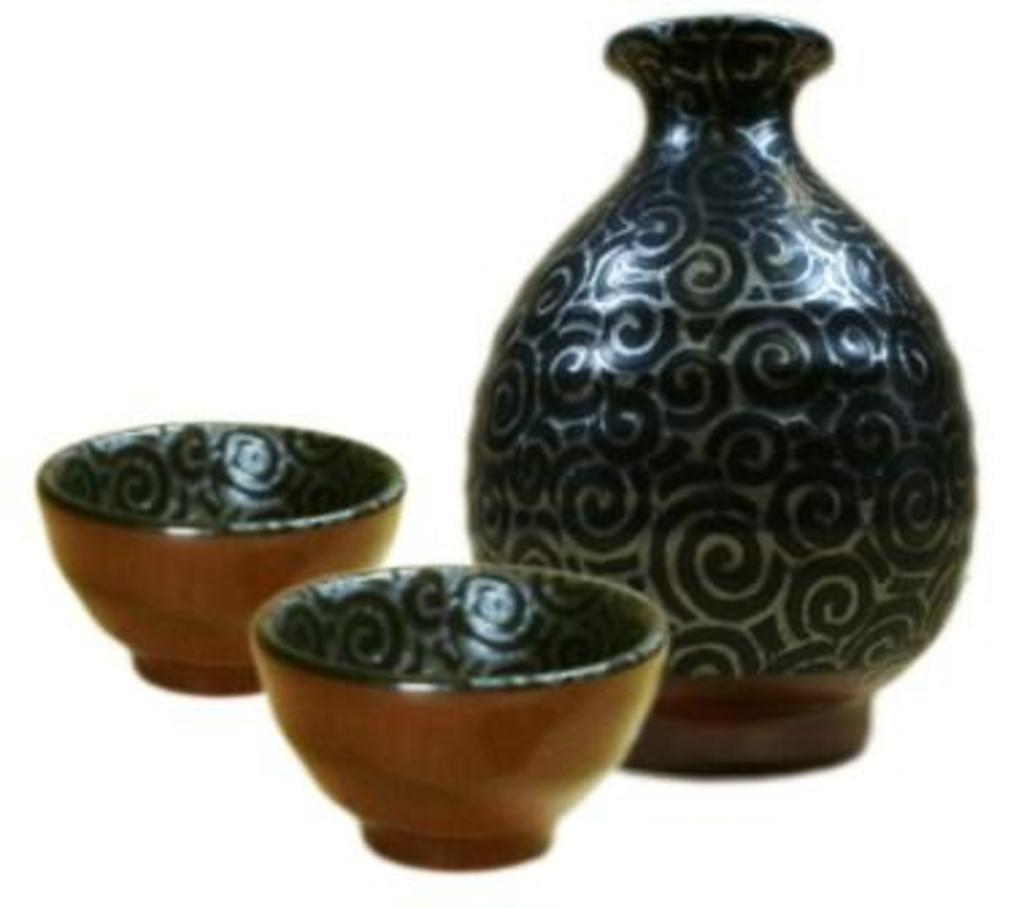What type of object is in the image? There is a ceramic pot in the image. How many ceramic bowls are in the image? There are two ceramic bowls in the image. Where are the bowls placed in relation to the pot? The bowls are kept beside the pot. What type of basket is used to carry the ceramic pot in the image? There is no basket present in the image, and the ceramic pot is not being carried. What type of industry is depicted in the image? There is no depiction of an industry in the image; it features ceramic pottery. 